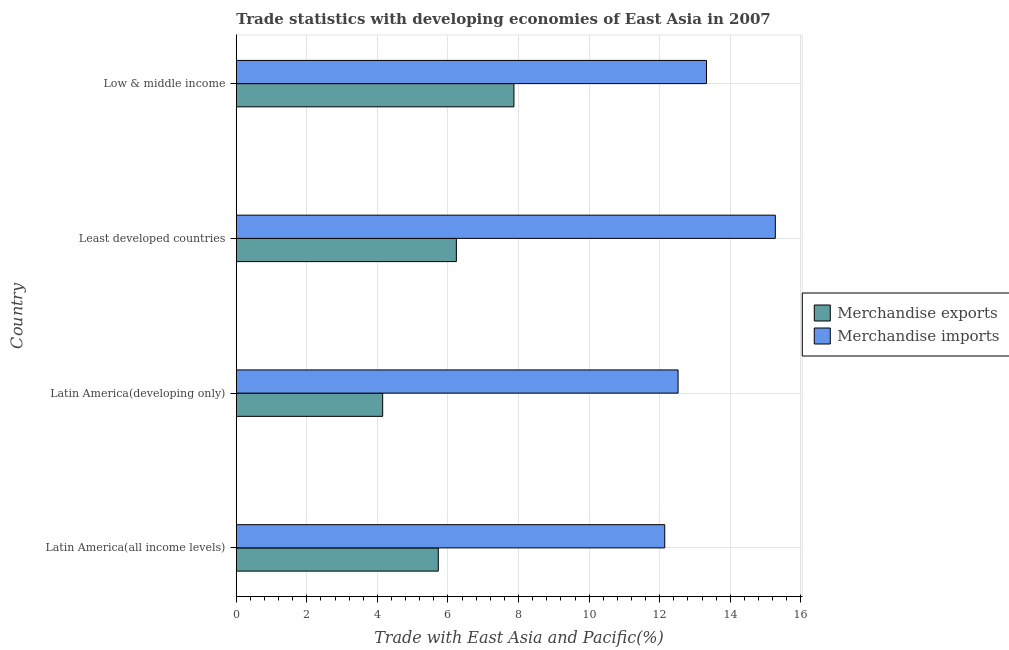How many different coloured bars are there?
Provide a short and direct response. 2. Are the number of bars on each tick of the Y-axis equal?
Your answer should be very brief. Yes. How many bars are there on the 4th tick from the top?
Ensure brevity in your answer.  2. How many bars are there on the 1st tick from the bottom?
Your answer should be very brief. 2. What is the merchandise exports in Low & middle income?
Give a very brief answer. 7.87. Across all countries, what is the maximum merchandise exports?
Offer a terse response. 7.87. Across all countries, what is the minimum merchandise exports?
Offer a terse response. 4.15. In which country was the merchandise imports maximum?
Ensure brevity in your answer.  Least developed countries. In which country was the merchandise exports minimum?
Offer a terse response. Latin America(developing only). What is the total merchandise exports in the graph?
Your response must be concise. 23.98. What is the difference between the merchandise exports in Latin America(developing only) and that in Low & middle income?
Provide a short and direct response. -3.72. What is the difference between the merchandise exports in Latin America(developing only) and the merchandise imports in Latin America(all income levels)?
Keep it short and to the point. -7.99. What is the average merchandise exports per country?
Give a very brief answer. 6. What is the difference between the merchandise exports and merchandise imports in Latin America(developing only)?
Give a very brief answer. -8.37. What is the ratio of the merchandise exports in Latin America(all income levels) to that in Latin America(developing only)?
Your answer should be compact. 1.38. Is the merchandise imports in Least developed countries less than that in Low & middle income?
Make the answer very short. No. What is the difference between the highest and the second highest merchandise exports?
Offer a terse response. 1.63. What is the difference between the highest and the lowest merchandise exports?
Make the answer very short. 3.72. What does the 2nd bar from the top in Low & middle income represents?
Ensure brevity in your answer.  Merchandise exports. Are all the bars in the graph horizontal?
Your response must be concise. Yes. How many countries are there in the graph?
Offer a terse response. 4. Are the values on the major ticks of X-axis written in scientific E-notation?
Make the answer very short. No. Does the graph contain grids?
Your response must be concise. Yes. Where does the legend appear in the graph?
Offer a terse response. Center right. What is the title of the graph?
Offer a terse response. Trade statistics with developing economies of East Asia in 2007. What is the label or title of the X-axis?
Your answer should be compact. Trade with East Asia and Pacific(%). What is the label or title of the Y-axis?
Offer a very short reply. Country. What is the Trade with East Asia and Pacific(%) of Merchandise exports in Latin America(all income levels)?
Give a very brief answer. 5.73. What is the Trade with East Asia and Pacific(%) of Merchandise imports in Latin America(all income levels)?
Offer a terse response. 12.14. What is the Trade with East Asia and Pacific(%) in Merchandise exports in Latin America(developing only)?
Provide a succinct answer. 4.15. What is the Trade with East Asia and Pacific(%) in Merchandise imports in Latin America(developing only)?
Ensure brevity in your answer.  12.52. What is the Trade with East Asia and Pacific(%) of Merchandise exports in Least developed countries?
Your answer should be compact. 6.24. What is the Trade with East Asia and Pacific(%) in Merchandise imports in Least developed countries?
Give a very brief answer. 15.28. What is the Trade with East Asia and Pacific(%) of Merchandise exports in Low & middle income?
Your response must be concise. 7.87. What is the Trade with East Asia and Pacific(%) in Merchandise imports in Low & middle income?
Your response must be concise. 13.33. Across all countries, what is the maximum Trade with East Asia and Pacific(%) in Merchandise exports?
Offer a very short reply. 7.87. Across all countries, what is the maximum Trade with East Asia and Pacific(%) of Merchandise imports?
Make the answer very short. 15.28. Across all countries, what is the minimum Trade with East Asia and Pacific(%) of Merchandise exports?
Ensure brevity in your answer.  4.15. Across all countries, what is the minimum Trade with East Asia and Pacific(%) of Merchandise imports?
Make the answer very short. 12.14. What is the total Trade with East Asia and Pacific(%) in Merchandise exports in the graph?
Keep it short and to the point. 23.98. What is the total Trade with East Asia and Pacific(%) of Merchandise imports in the graph?
Make the answer very short. 53.26. What is the difference between the Trade with East Asia and Pacific(%) in Merchandise exports in Latin America(all income levels) and that in Latin America(developing only)?
Your answer should be compact. 1.58. What is the difference between the Trade with East Asia and Pacific(%) in Merchandise imports in Latin America(all income levels) and that in Latin America(developing only)?
Provide a short and direct response. -0.38. What is the difference between the Trade with East Asia and Pacific(%) of Merchandise exports in Latin America(all income levels) and that in Least developed countries?
Provide a succinct answer. -0.51. What is the difference between the Trade with East Asia and Pacific(%) in Merchandise imports in Latin America(all income levels) and that in Least developed countries?
Keep it short and to the point. -3.13. What is the difference between the Trade with East Asia and Pacific(%) of Merchandise exports in Latin America(all income levels) and that in Low & middle income?
Provide a short and direct response. -2.14. What is the difference between the Trade with East Asia and Pacific(%) in Merchandise imports in Latin America(all income levels) and that in Low & middle income?
Your answer should be very brief. -1.18. What is the difference between the Trade with East Asia and Pacific(%) of Merchandise exports in Latin America(developing only) and that in Least developed countries?
Your response must be concise. -2.09. What is the difference between the Trade with East Asia and Pacific(%) of Merchandise imports in Latin America(developing only) and that in Least developed countries?
Your answer should be compact. -2.76. What is the difference between the Trade with East Asia and Pacific(%) of Merchandise exports in Latin America(developing only) and that in Low & middle income?
Your response must be concise. -3.72. What is the difference between the Trade with East Asia and Pacific(%) in Merchandise imports in Latin America(developing only) and that in Low & middle income?
Your answer should be compact. -0.8. What is the difference between the Trade with East Asia and Pacific(%) of Merchandise exports in Least developed countries and that in Low & middle income?
Provide a short and direct response. -1.63. What is the difference between the Trade with East Asia and Pacific(%) in Merchandise imports in Least developed countries and that in Low & middle income?
Keep it short and to the point. 1.95. What is the difference between the Trade with East Asia and Pacific(%) of Merchandise exports in Latin America(all income levels) and the Trade with East Asia and Pacific(%) of Merchandise imports in Latin America(developing only)?
Your answer should be very brief. -6.8. What is the difference between the Trade with East Asia and Pacific(%) of Merchandise exports in Latin America(all income levels) and the Trade with East Asia and Pacific(%) of Merchandise imports in Least developed countries?
Provide a short and direct response. -9.55. What is the difference between the Trade with East Asia and Pacific(%) in Merchandise exports in Latin America(all income levels) and the Trade with East Asia and Pacific(%) in Merchandise imports in Low & middle income?
Your response must be concise. -7.6. What is the difference between the Trade with East Asia and Pacific(%) of Merchandise exports in Latin America(developing only) and the Trade with East Asia and Pacific(%) of Merchandise imports in Least developed countries?
Give a very brief answer. -11.13. What is the difference between the Trade with East Asia and Pacific(%) of Merchandise exports in Latin America(developing only) and the Trade with East Asia and Pacific(%) of Merchandise imports in Low & middle income?
Your answer should be compact. -9.18. What is the difference between the Trade with East Asia and Pacific(%) of Merchandise exports in Least developed countries and the Trade with East Asia and Pacific(%) of Merchandise imports in Low & middle income?
Your response must be concise. -7.09. What is the average Trade with East Asia and Pacific(%) of Merchandise exports per country?
Ensure brevity in your answer.  6. What is the average Trade with East Asia and Pacific(%) in Merchandise imports per country?
Offer a terse response. 13.32. What is the difference between the Trade with East Asia and Pacific(%) of Merchandise exports and Trade with East Asia and Pacific(%) of Merchandise imports in Latin America(all income levels)?
Ensure brevity in your answer.  -6.42. What is the difference between the Trade with East Asia and Pacific(%) of Merchandise exports and Trade with East Asia and Pacific(%) of Merchandise imports in Latin America(developing only)?
Offer a terse response. -8.37. What is the difference between the Trade with East Asia and Pacific(%) in Merchandise exports and Trade with East Asia and Pacific(%) in Merchandise imports in Least developed countries?
Offer a very short reply. -9.04. What is the difference between the Trade with East Asia and Pacific(%) in Merchandise exports and Trade with East Asia and Pacific(%) in Merchandise imports in Low & middle income?
Provide a short and direct response. -5.46. What is the ratio of the Trade with East Asia and Pacific(%) of Merchandise exports in Latin America(all income levels) to that in Latin America(developing only)?
Make the answer very short. 1.38. What is the ratio of the Trade with East Asia and Pacific(%) of Merchandise imports in Latin America(all income levels) to that in Latin America(developing only)?
Give a very brief answer. 0.97. What is the ratio of the Trade with East Asia and Pacific(%) in Merchandise exports in Latin America(all income levels) to that in Least developed countries?
Provide a succinct answer. 0.92. What is the ratio of the Trade with East Asia and Pacific(%) of Merchandise imports in Latin America(all income levels) to that in Least developed countries?
Give a very brief answer. 0.79. What is the ratio of the Trade with East Asia and Pacific(%) in Merchandise exports in Latin America(all income levels) to that in Low & middle income?
Keep it short and to the point. 0.73. What is the ratio of the Trade with East Asia and Pacific(%) of Merchandise imports in Latin America(all income levels) to that in Low & middle income?
Your answer should be compact. 0.91. What is the ratio of the Trade with East Asia and Pacific(%) in Merchandise exports in Latin America(developing only) to that in Least developed countries?
Provide a short and direct response. 0.67. What is the ratio of the Trade with East Asia and Pacific(%) in Merchandise imports in Latin America(developing only) to that in Least developed countries?
Offer a very short reply. 0.82. What is the ratio of the Trade with East Asia and Pacific(%) of Merchandise exports in Latin America(developing only) to that in Low & middle income?
Provide a short and direct response. 0.53. What is the ratio of the Trade with East Asia and Pacific(%) in Merchandise imports in Latin America(developing only) to that in Low & middle income?
Your answer should be compact. 0.94. What is the ratio of the Trade with East Asia and Pacific(%) of Merchandise exports in Least developed countries to that in Low & middle income?
Give a very brief answer. 0.79. What is the ratio of the Trade with East Asia and Pacific(%) in Merchandise imports in Least developed countries to that in Low & middle income?
Your answer should be compact. 1.15. What is the difference between the highest and the second highest Trade with East Asia and Pacific(%) in Merchandise exports?
Ensure brevity in your answer.  1.63. What is the difference between the highest and the second highest Trade with East Asia and Pacific(%) in Merchandise imports?
Your response must be concise. 1.95. What is the difference between the highest and the lowest Trade with East Asia and Pacific(%) of Merchandise exports?
Keep it short and to the point. 3.72. What is the difference between the highest and the lowest Trade with East Asia and Pacific(%) of Merchandise imports?
Make the answer very short. 3.13. 